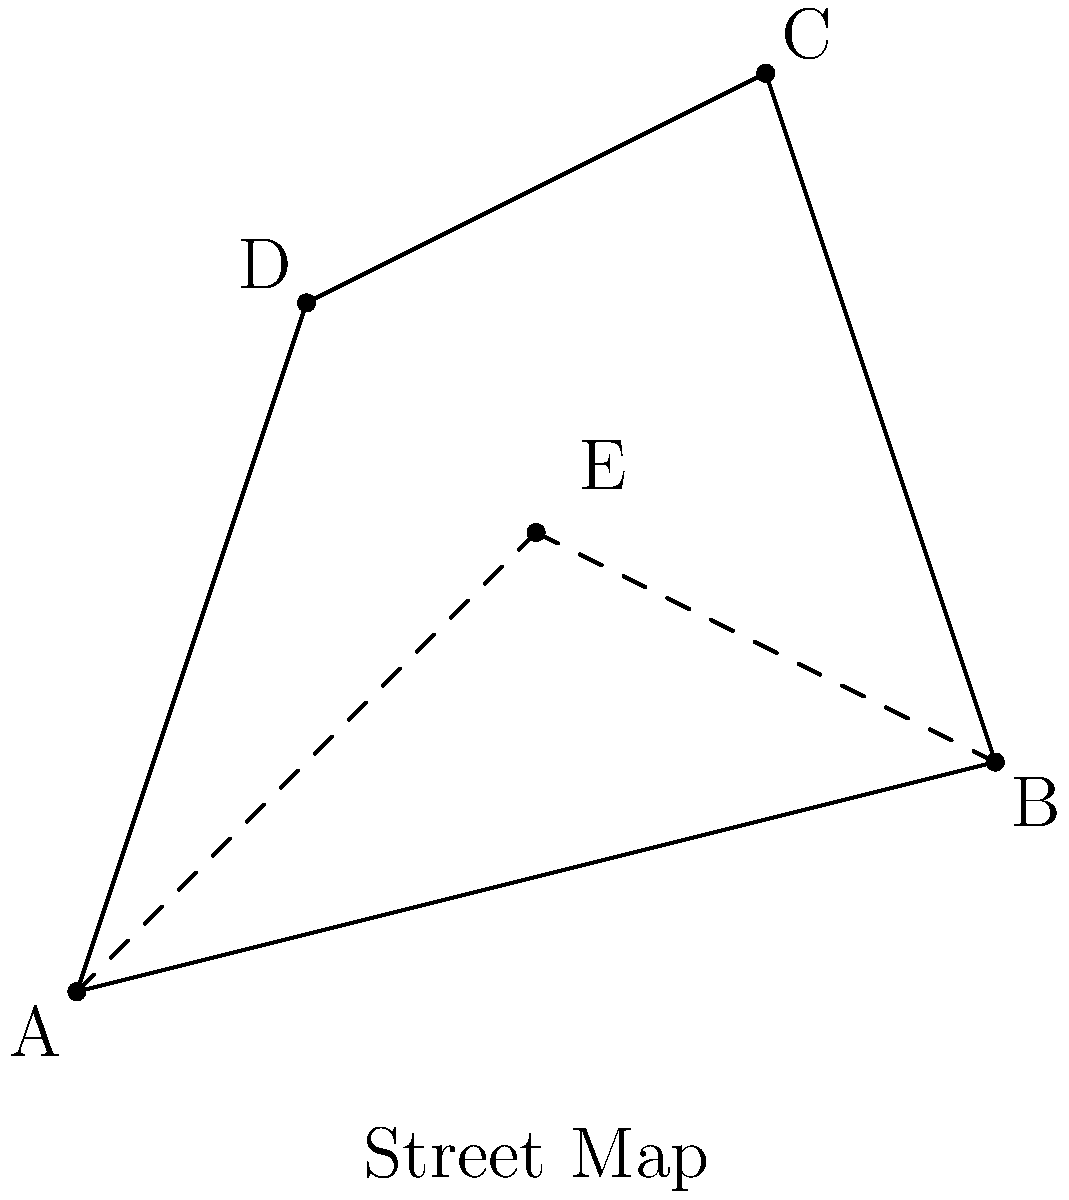You're planning the safest route to a support meeting. The street map shows your starting point (A) and the meeting location (C). Point E represents a neutral territory. If you rotate the map 90° clockwise around point E, which path becomes the shortest route from A to C? To solve this problem, let's follow these steps:

1) First, we need to understand what a 90° clockwise rotation around point E means. It will move each point 90° clockwise with E as the center of rotation.

2) After rotation:
   - A will move to where D is
   - B will move to where A is
   - C will move to where B is
   - D will move to where C is

3) Now, let's consider the possible paths from A to C:
   a) A -> E -> C (using neutral territory)
   b) A -> B -> C
   c) A -> D -> C

4) After rotation:
   a) D -> E -> B
   b) D -> A -> B
   c) D -> C -> B

5) The path D -> A -> B becomes the direct line from the new position of A to the new position of C.

6) In a rotation, distances are preserved. So, the shortest path after rotation was also the shortest path before rotation.

7) Therefore, the path A -> B -> C was the shortest route before rotation, and it becomes the direct line after rotation.
Answer: A -> B -> C 